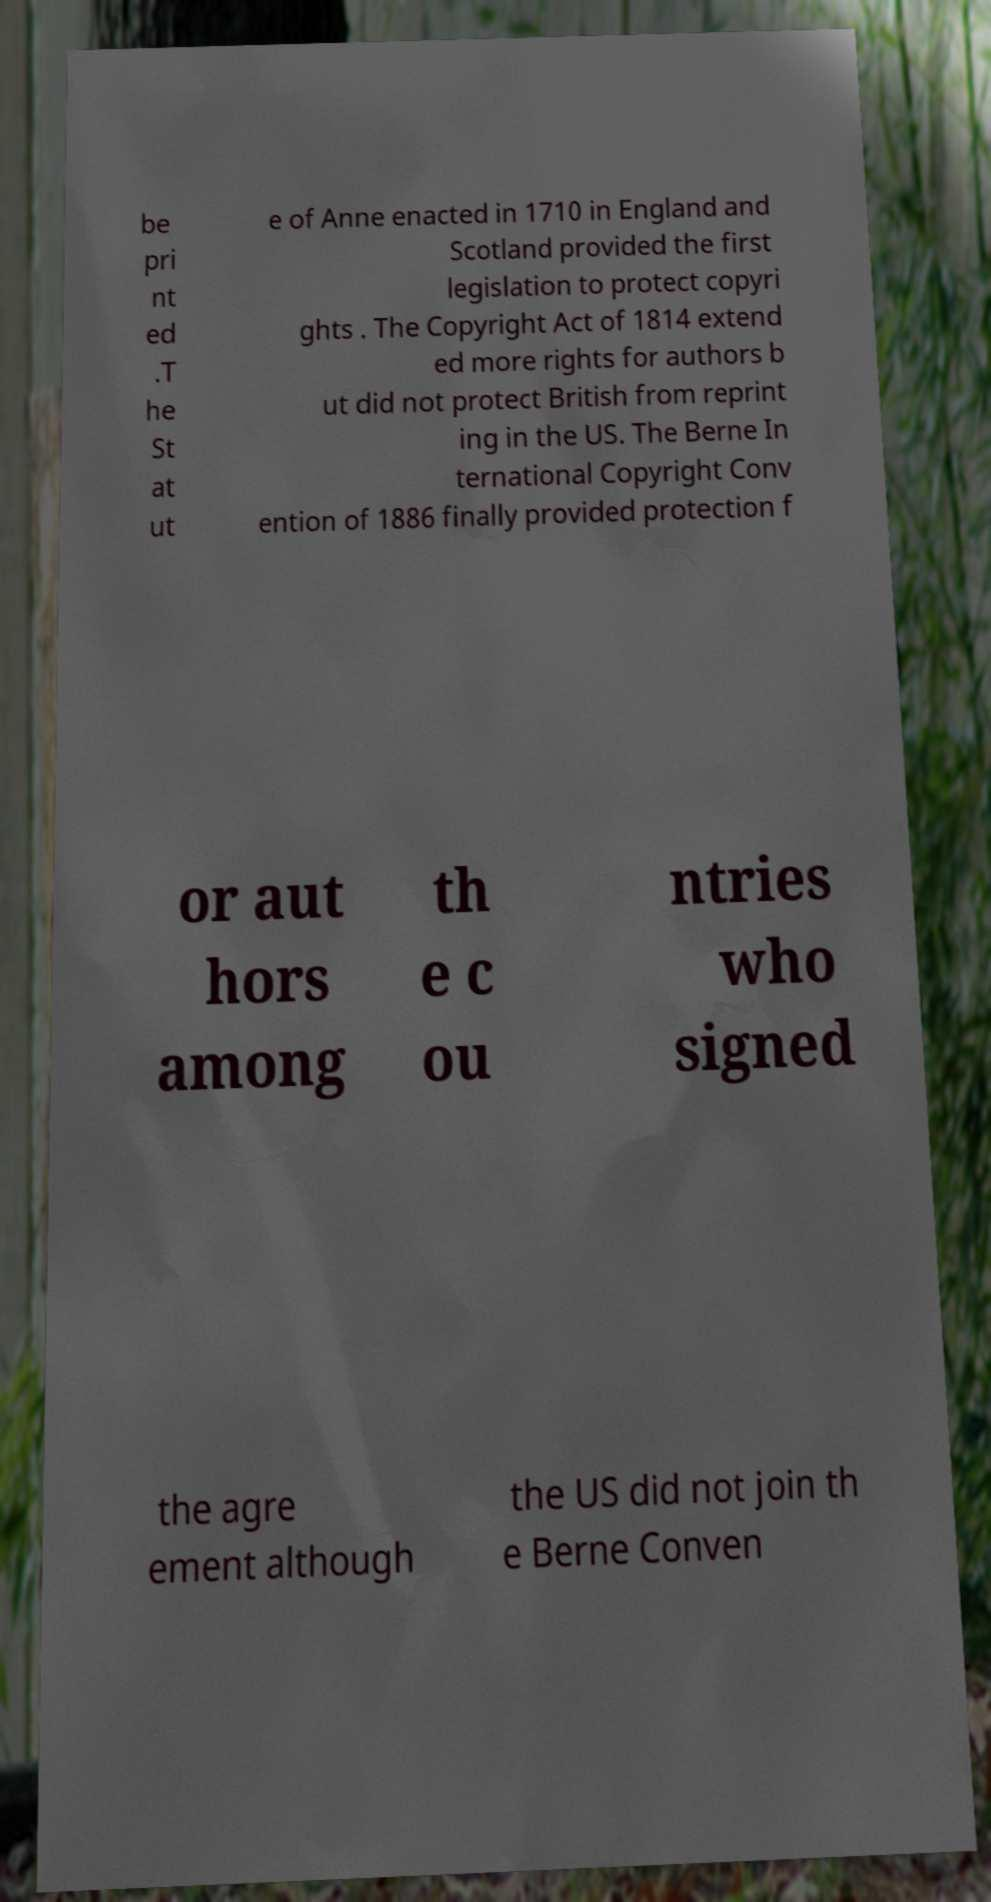Can you read and provide the text displayed in the image?This photo seems to have some interesting text. Can you extract and type it out for me? be pri nt ed .T he St at ut e of Anne enacted in 1710 in England and Scotland provided the first legislation to protect copyri ghts . The Copyright Act of 1814 extend ed more rights for authors b ut did not protect British from reprint ing in the US. The Berne In ternational Copyright Conv ention of 1886 finally provided protection f or aut hors among th e c ou ntries who signed the agre ement although the US did not join th e Berne Conven 